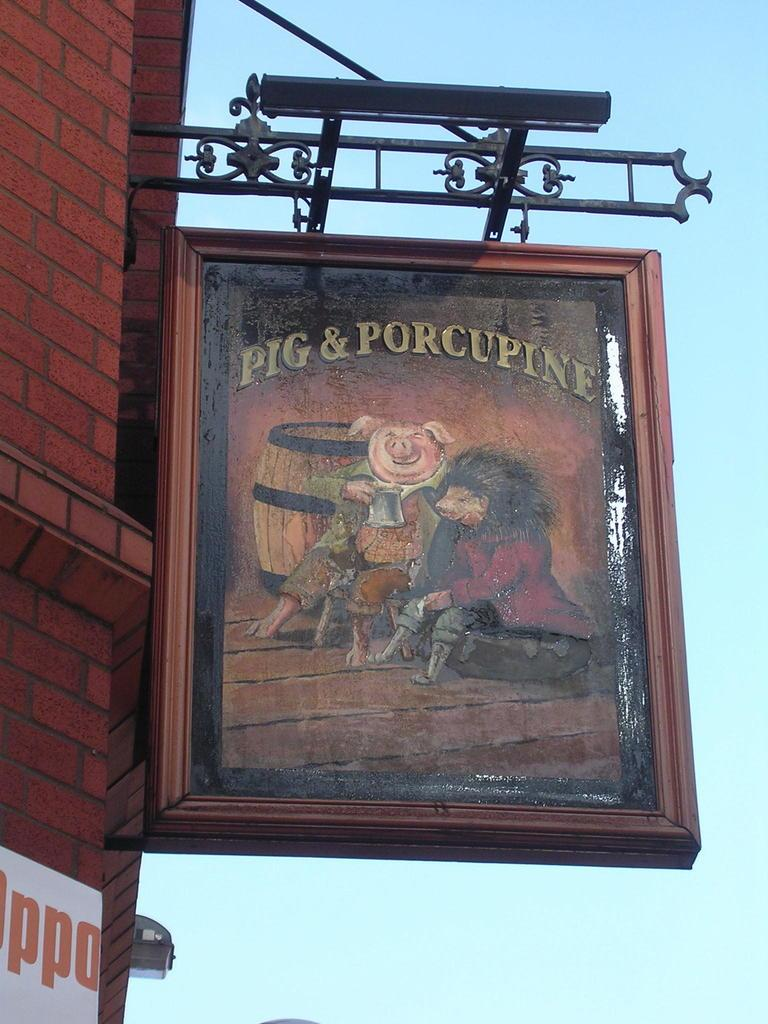<image>
Relay a brief, clear account of the picture shown. a sign that has the word pig on it 